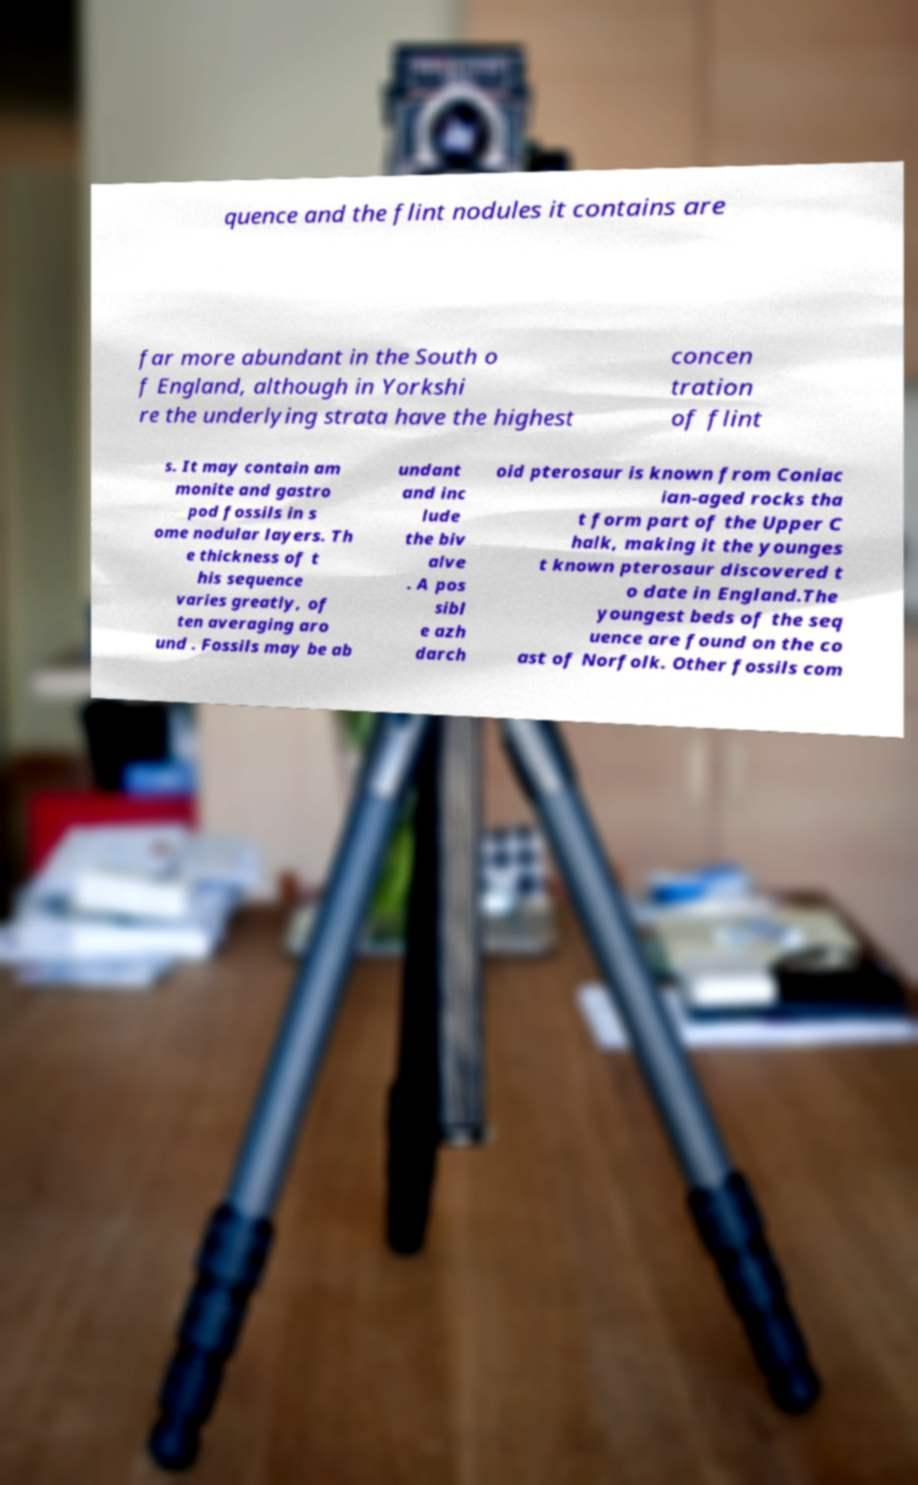Please identify and transcribe the text found in this image. quence and the flint nodules it contains are far more abundant in the South o f England, although in Yorkshi re the underlying strata have the highest concen tration of flint s. It may contain am monite and gastro pod fossils in s ome nodular layers. Th e thickness of t his sequence varies greatly, of ten averaging aro und . Fossils may be ab undant and inc lude the biv alve . A pos sibl e azh darch oid pterosaur is known from Coniac ian-aged rocks tha t form part of the Upper C halk, making it the younges t known pterosaur discovered t o date in England.The youngest beds of the seq uence are found on the co ast of Norfolk. Other fossils com 